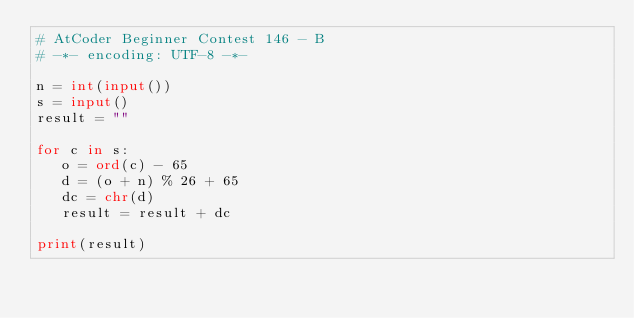<code> <loc_0><loc_0><loc_500><loc_500><_Python_># AtCoder Beginner Contest 146 - B
# -*- encoding: UTF-8 -*-

n = int(input())
s = input()
result = ""

for c in s:
   o = ord(c) - 65
   d = (o + n) % 26 + 65
   dc = chr(d)
   result = result + dc

print(result)
</code> 